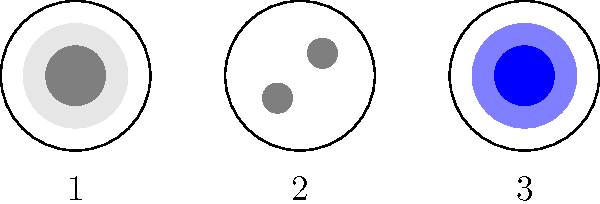Given the cross-sectional diagrams of three different network cables, which one is most likely to be a fiber optic cable, and why is it particularly suitable for long-distance data transmission? Let's analyze each cable type step-by-step:

1. Cable 1: This appears to be a coaxial cable. It has a central conductor surrounded by an insulating layer and an outer conductive shield.

2. Cable 2: This looks like a twisted pair cable. It contains two separate wires, which in practice would be twisted together to reduce electromagnetic interference.

3. Cable 3: This is likely a fiber optic cable. It has a central core surrounded by a cladding layer, which is typical for fiber optic cables.

Fiber optic cable (Cable 3) is most suitable for long-distance data transmission because:

a) It uses light signals instead of electrical signals, which suffer less degradation over long distances.

b) Fiber optic cables are immune to electromagnetic interference, unlike copper-based cables.

c) They can carry much more data (higher bandwidth) than traditional copper cables.

d) Fiber optic cables experience less signal loss (attenuation) over long distances, meaning the signal can travel further without needing amplification.

e) They are thinner and lighter than copper cables, making them easier to install and maintain over long distances.

These characteristics make fiber optic cables ideal for long-distance, high-speed data transmission in modern network infrastructure.
Answer: Cable 3; uses light signals with less degradation and interference over long distances. 